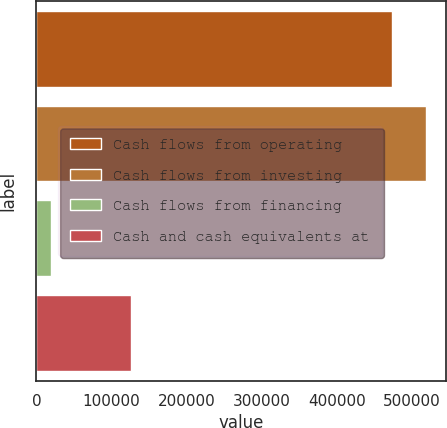Convert chart. <chart><loc_0><loc_0><loc_500><loc_500><bar_chart><fcel>Cash flows from operating<fcel>Cash flows from investing<fcel>Cash flows from financing<fcel>Cash and cash equivalents at<nl><fcel>472948<fcel>518960<fcel>19857<fcel>125933<nl></chart> 